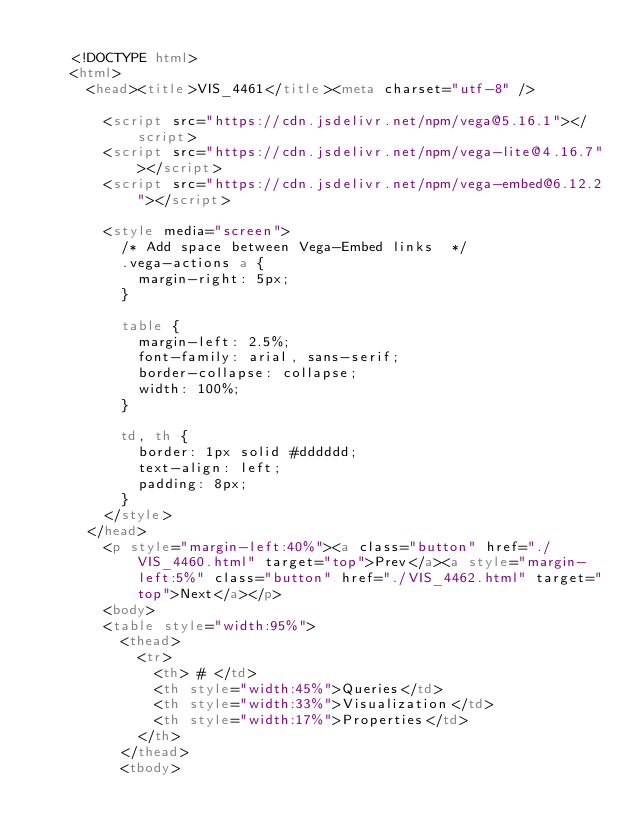<code> <loc_0><loc_0><loc_500><loc_500><_HTML_>
    <!DOCTYPE html>
    <html>
      <head><title>VIS_4461</title><meta charset="utf-8" />

        <script src="https://cdn.jsdelivr.net/npm/vega@5.16.1"></script>
        <script src="https://cdn.jsdelivr.net/npm/vega-lite@4.16.7"></script>
        <script src="https://cdn.jsdelivr.net/npm/vega-embed@6.12.2"></script>

        <style media="screen">
          /* Add space between Vega-Embed links  */
          .vega-actions a {
            margin-right: 5px;
          }

          table {
            margin-left: 2.5%;
            font-family: arial, sans-serif;
            border-collapse: collapse;
            width: 100%;
          }

          td, th {
            border: 1px solid #dddddd;
            text-align: left;
            padding: 8px;
          }
        </style>
      </head>
        <p style="margin-left:40%"><a class="button" href="./VIS_4460.html" target="top">Prev</a><a style="margin-left:5%" class="button" href="./VIS_4462.html" target="top">Next</a></p>
        <body>
        <table style="width:95%">
          <thead>
            <tr>
              <th> # </td>
              <th style="width:45%">Queries</td>
              <th style="width:33%">Visualization</td>
              <th style="width:17%">Properties</td>
            </th>
          </thead>
          <tbody></code> 